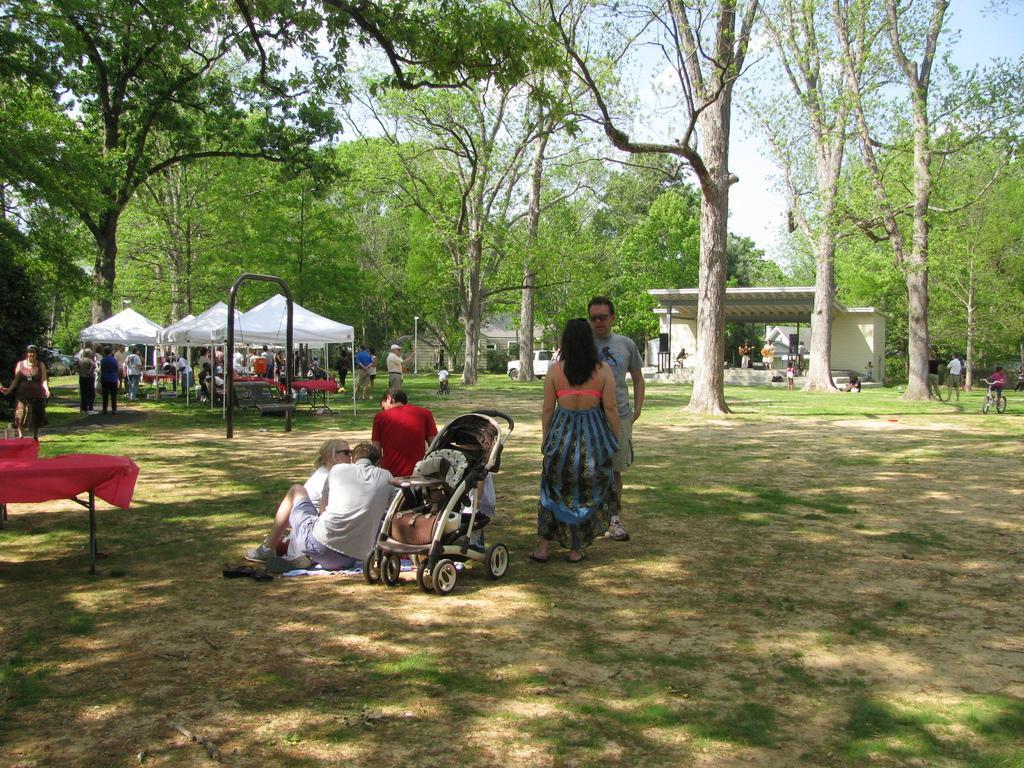How would you summarize this image in a sentence or two? In this image I can see there are so many trees and some people standing under the tent and some sitting on the ground beside the trolley, beside them there is a stage and vehicle. 